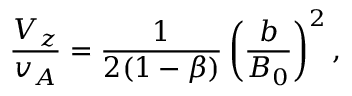<formula> <loc_0><loc_0><loc_500><loc_500>\frac { V _ { z } } { v _ { A } } = \frac { 1 } { 2 ( 1 - \beta ) } \left ( \frac { b } { B _ { 0 } } \right ) ^ { 2 } ,</formula> 